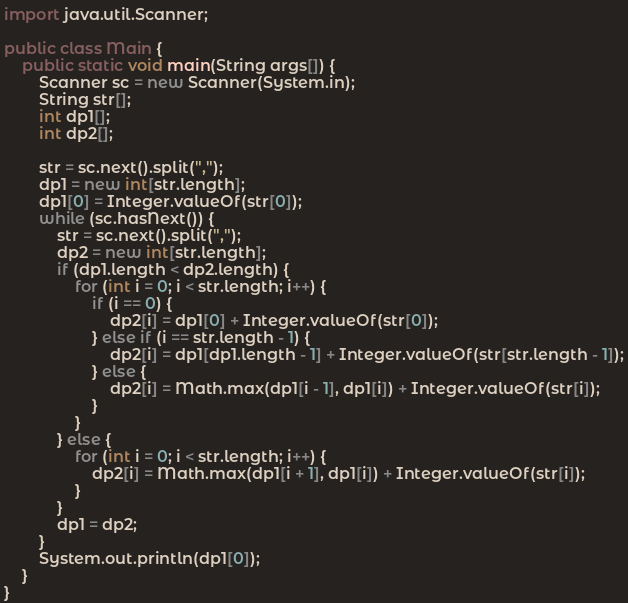Convert code to text. <code><loc_0><loc_0><loc_500><loc_500><_Java_>import java.util.Scanner;

public class Main {
	public static void main(String args[]) {
		Scanner sc = new Scanner(System.in);
		String str[];
		int dp1[];
		int dp2[];

		str = sc.next().split(",");
		dp1 = new int[str.length];
		dp1[0] = Integer.valueOf(str[0]);
		while (sc.hasNext()) {
			str = sc.next().split(",");
			dp2 = new int[str.length];
			if (dp1.length < dp2.length) {
				for (int i = 0; i < str.length; i++) {
					if (i == 0) {
						dp2[i] = dp1[0] + Integer.valueOf(str[0]);
					} else if (i == str.length - 1) {
						dp2[i] = dp1[dp1.length - 1] + Integer.valueOf(str[str.length - 1]);
					} else {
						dp2[i] = Math.max(dp1[i - 1], dp1[i]) + Integer.valueOf(str[i]);
					}
				}
			} else {
				for (int i = 0; i < str.length; i++) {
					dp2[i] = Math.max(dp1[i + 1], dp1[i]) + Integer.valueOf(str[i]);
				}
			}
			dp1 = dp2;
		}
		System.out.println(dp1[0]);
	}
}</code> 